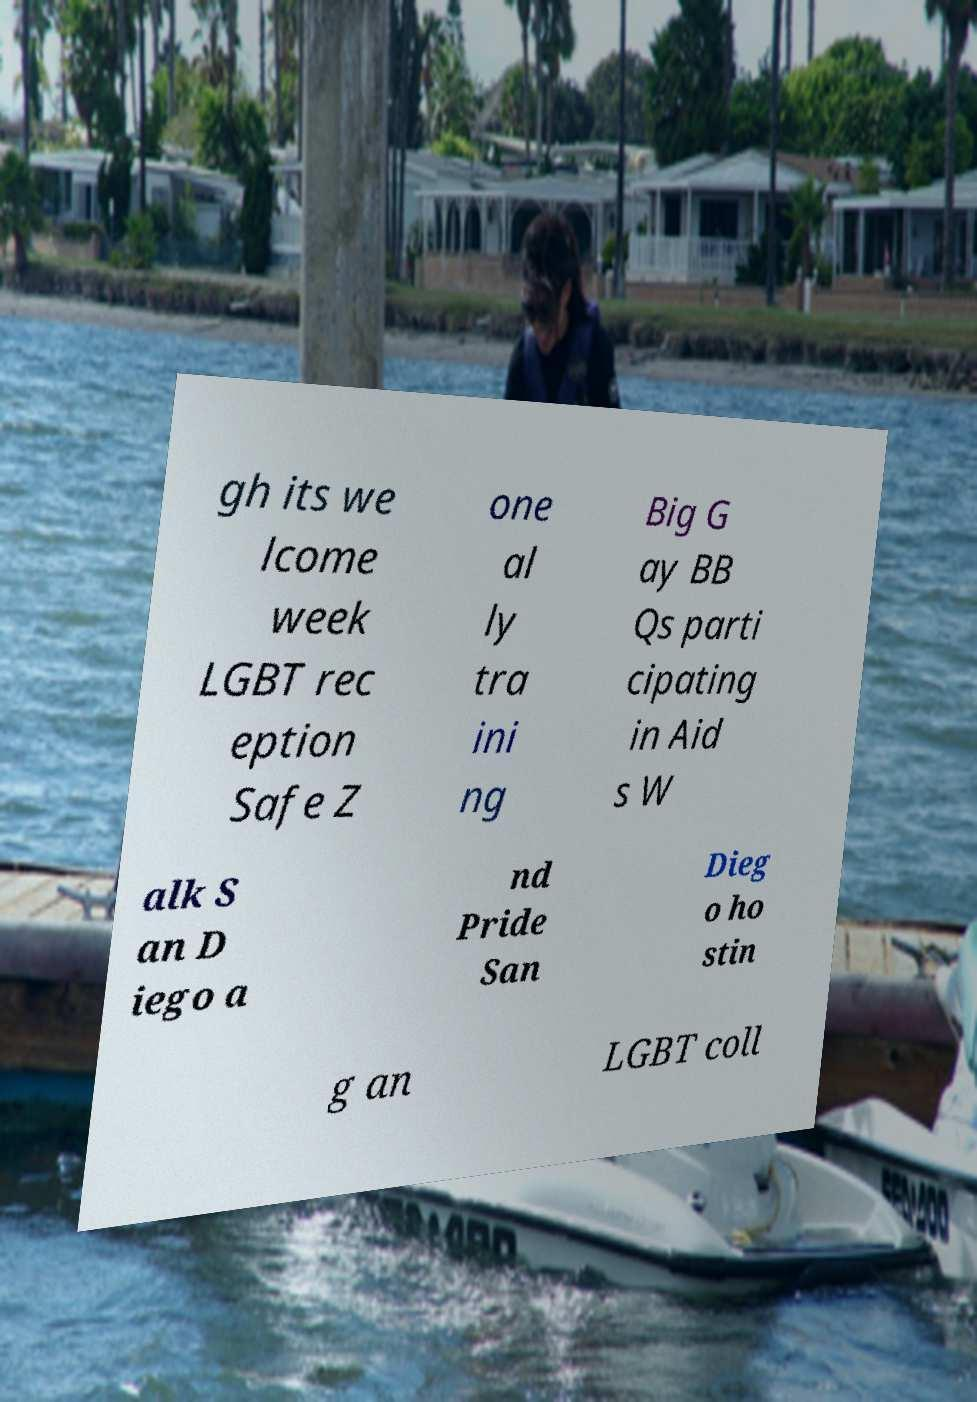There's text embedded in this image that I need extracted. Can you transcribe it verbatim? gh its we lcome week LGBT rec eption Safe Z one al ly tra ini ng Big G ay BB Qs parti cipating in Aid s W alk S an D iego a nd Pride San Dieg o ho stin g an LGBT coll 